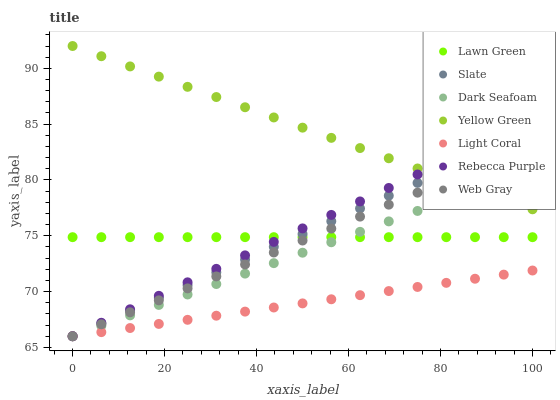Does Light Coral have the minimum area under the curve?
Answer yes or no. Yes. Does Yellow Green have the maximum area under the curve?
Answer yes or no. Yes. Does Web Gray have the minimum area under the curve?
Answer yes or no. No. Does Web Gray have the maximum area under the curve?
Answer yes or no. No. Is Web Gray the smoothest?
Answer yes or no. Yes. Is Lawn Green the roughest?
Answer yes or no. Yes. Is Yellow Green the smoothest?
Answer yes or no. No. Is Yellow Green the roughest?
Answer yes or no. No. Does Web Gray have the lowest value?
Answer yes or no. Yes. Does Yellow Green have the lowest value?
Answer yes or no. No. Does Yellow Green have the highest value?
Answer yes or no. Yes. Does Web Gray have the highest value?
Answer yes or no. No. Is Light Coral less than Yellow Green?
Answer yes or no. Yes. Is Lawn Green greater than Light Coral?
Answer yes or no. Yes. Does Dark Seafoam intersect Slate?
Answer yes or no. Yes. Is Dark Seafoam less than Slate?
Answer yes or no. No. Is Dark Seafoam greater than Slate?
Answer yes or no. No. Does Light Coral intersect Yellow Green?
Answer yes or no. No. 